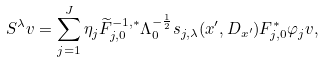Convert formula to latex. <formula><loc_0><loc_0><loc_500><loc_500>S ^ { \lambda } v = \sum _ { j = 1 } ^ { J } \eta _ { j } \widetilde { F } ^ { - 1 , \ast } _ { j , 0 } \Lambda _ { 0 } ^ { - \frac { 1 } { 2 } } s _ { j , \lambda } ( x ^ { \prime } , D _ { x ^ { \prime } } ) F ^ { \ast } _ { j , 0 } \varphi _ { j } v ,</formula> 